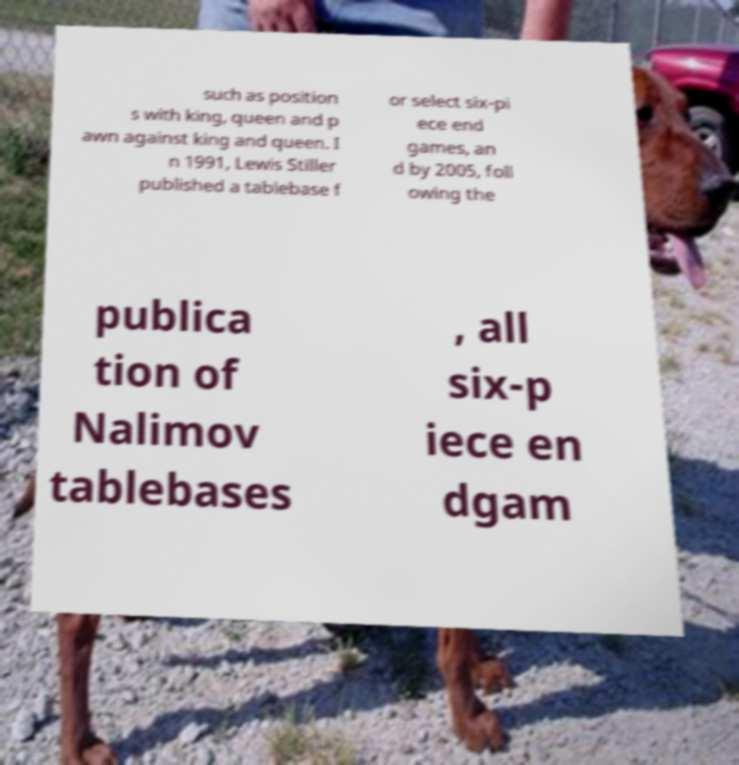There's text embedded in this image that I need extracted. Can you transcribe it verbatim? such as position s with king, queen and p awn against king and queen. I n 1991, Lewis Stiller published a tablebase f or select six-pi ece end games, an d by 2005, foll owing the publica tion of Nalimov tablebases , all six-p iece en dgam 